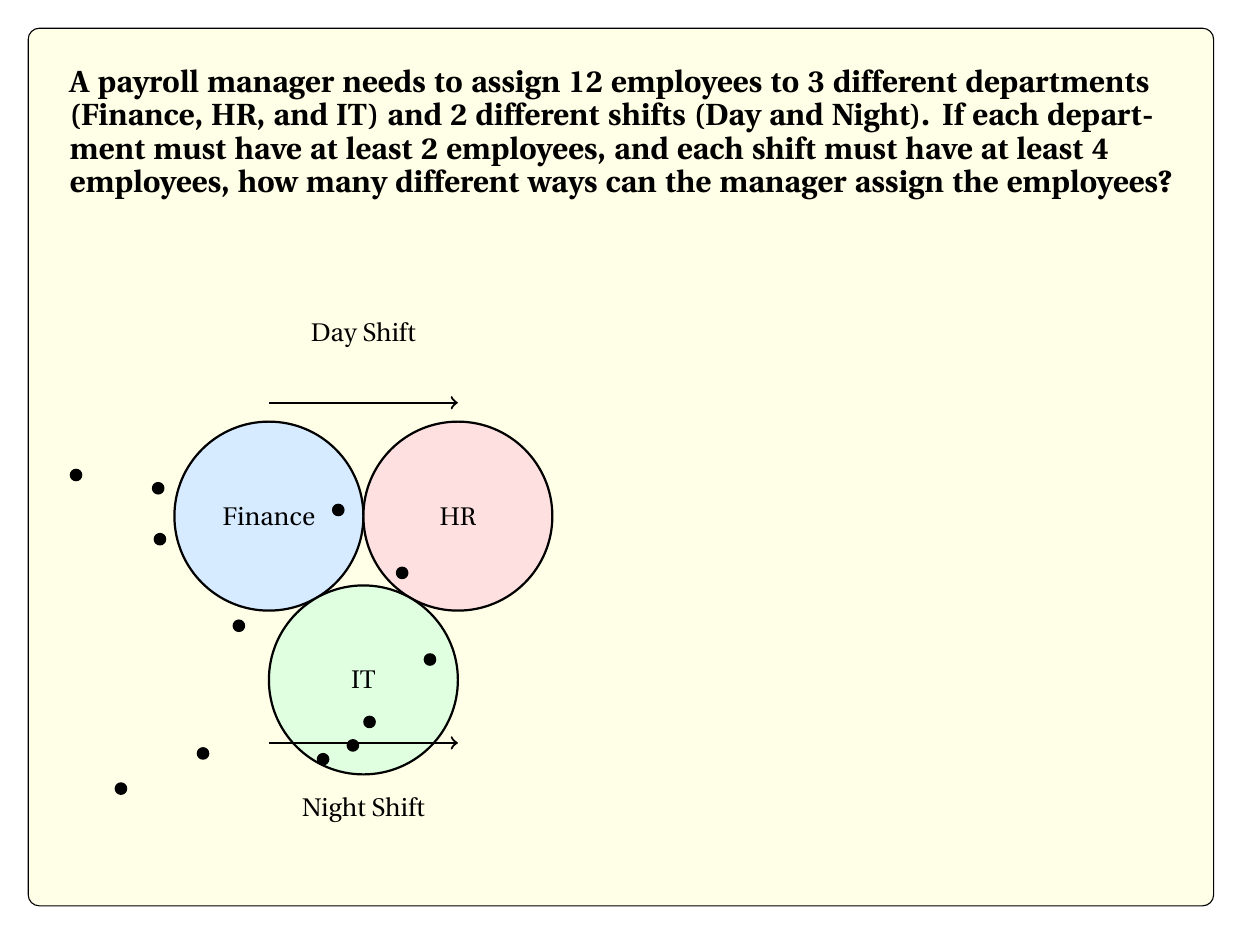Can you answer this question? Let's approach this step-by-step:

1) First, we need to distribute the employees among the departments:
   - We know each department must have at least 2 employees.
   - So we start by assigning 2 employees to each department: 2 + 2 + 2 = 6
   - We have 6 employees left to distribute among the 3 departments.
   - This is a stars and bars problem with 6 stars and 2 bars.
   - The number of ways to do this is $\binom{6+2}{2} = \binom{8}{2} = 28$

2) Now, for each of these 28 department distributions, we need to assign shifts:
   - We need at least 4 employees in each shift.
   - Let x be the number of employees in the day shift.
   - Then 12 - x is the number in the night shift.
   - We need: 4 ≤ x ≤ 8
   - So x can be 4, 5, 6, 7, or 8
   - That's 5 possible shift distributions for each department distribution.

3) For each department and shift distribution, we need to choose which specific employees are in each department and shift:
   - This is a multiplication of choices:
     $$\frac{12!}{a!b!c!} \cdot \frac{12!}{x!(12-x)!}$$
   where a, b, c are the number of employees in each department and x is the number in the day shift.

4) The total number of ways is the sum of all these possibilities:
   $$\sum_{i=1}^{28} \sum_{x=4}^{8} \frac{12!}{a_i!b_i!c_i!} \cdot \frac{12!}{x!(12-x)!}$$
   where $a_i, b_i, c_i$ are the department distributions for the i-th possibility.

5) This sum would be extremely large and time-consuming to calculate by hand, but it represents the total number of possible assignments.
Answer: $$\sum_{i=1}^{28} \sum_{x=4}^{8} \frac{12!}{a_i!b_i!c_i!} \cdot \frac{12!}{x!(12-x)!}$$ 